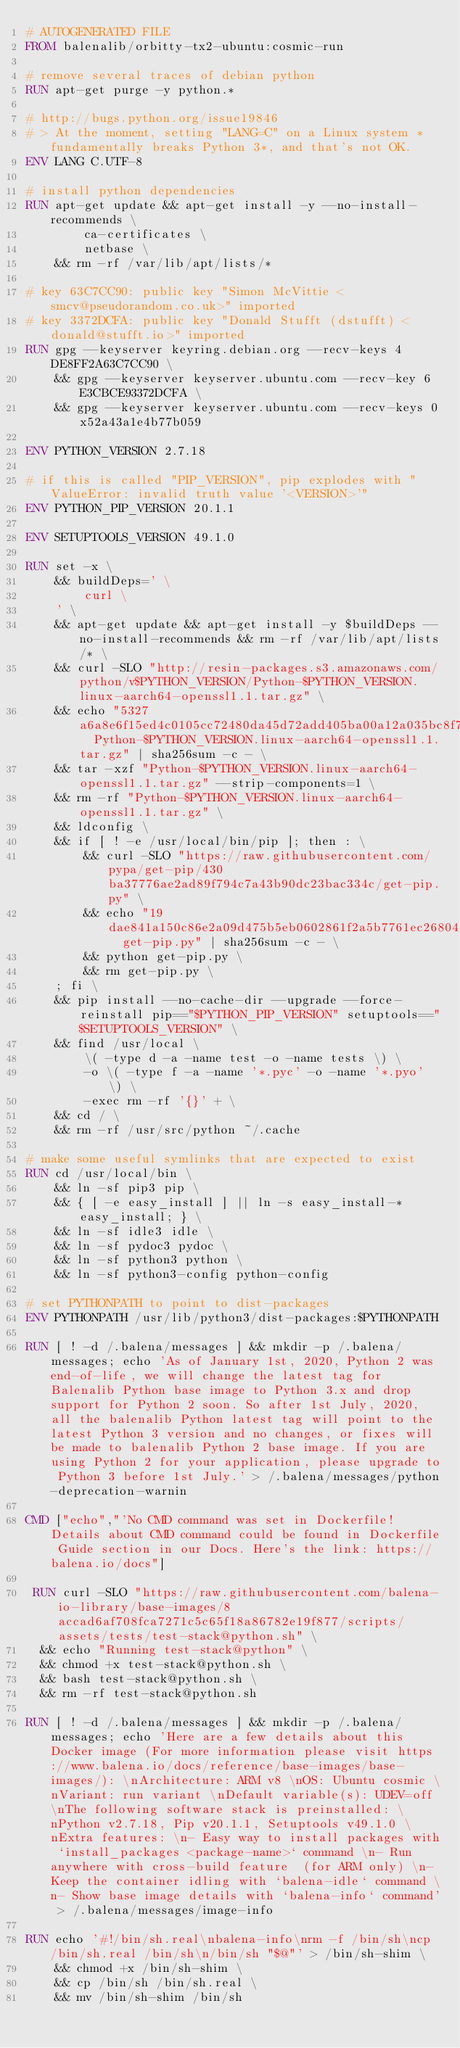Convert code to text. <code><loc_0><loc_0><loc_500><loc_500><_Dockerfile_># AUTOGENERATED FILE
FROM balenalib/orbitty-tx2-ubuntu:cosmic-run

# remove several traces of debian python
RUN apt-get purge -y python.*

# http://bugs.python.org/issue19846
# > At the moment, setting "LANG=C" on a Linux system *fundamentally breaks Python 3*, and that's not OK.
ENV LANG C.UTF-8

# install python dependencies
RUN apt-get update && apt-get install -y --no-install-recommends \
		ca-certificates \
		netbase \
	&& rm -rf /var/lib/apt/lists/*

# key 63C7CC90: public key "Simon McVittie <smcv@pseudorandom.co.uk>" imported
# key 3372DCFA: public key "Donald Stufft (dstufft) <donald@stufft.io>" imported
RUN gpg --keyserver keyring.debian.org --recv-keys 4DE8FF2A63C7CC90 \
	&& gpg --keyserver keyserver.ubuntu.com --recv-key 6E3CBCE93372DCFA \
	&& gpg --keyserver keyserver.ubuntu.com --recv-keys 0x52a43a1e4b77b059

ENV PYTHON_VERSION 2.7.18

# if this is called "PIP_VERSION", pip explodes with "ValueError: invalid truth value '<VERSION>'"
ENV PYTHON_PIP_VERSION 20.1.1

ENV SETUPTOOLS_VERSION 49.1.0

RUN set -x \
	&& buildDeps=' \
		curl \
	' \
	&& apt-get update && apt-get install -y $buildDeps --no-install-recommends && rm -rf /var/lib/apt/lists/* \
	&& curl -SLO "http://resin-packages.s3.amazonaws.com/python/v$PYTHON_VERSION/Python-$PYTHON_VERSION.linux-aarch64-openssl1.1.tar.gz" \
	&& echo "5327a6a8e6f15ed4c0105cc72480da45d72add405ba00a12a035bc8f7be76ee6  Python-$PYTHON_VERSION.linux-aarch64-openssl1.1.tar.gz" | sha256sum -c - \
	&& tar -xzf "Python-$PYTHON_VERSION.linux-aarch64-openssl1.1.tar.gz" --strip-components=1 \
	&& rm -rf "Python-$PYTHON_VERSION.linux-aarch64-openssl1.1.tar.gz" \
	&& ldconfig \
	&& if [ ! -e /usr/local/bin/pip ]; then : \
		&& curl -SLO "https://raw.githubusercontent.com/pypa/get-pip/430ba37776ae2ad89f794c7a43b90dc23bac334c/get-pip.py" \
		&& echo "19dae841a150c86e2a09d475b5eb0602861f2a5b7761ec268049a662dbd2bd0c  get-pip.py" | sha256sum -c - \
		&& python get-pip.py \
		&& rm get-pip.py \
	; fi \
	&& pip install --no-cache-dir --upgrade --force-reinstall pip=="$PYTHON_PIP_VERSION" setuptools=="$SETUPTOOLS_VERSION" \
	&& find /usr/local \
		\( -type d -a -name test -o -name tests \) \
		-o \( -type f -a -name '*.pyc' -o -name '*.pyo' \) \
		-exec rm -rf '{}' + \
	&& cd / \
	&& rm -rf /usr/src/python ~/.cache

# make some useful symlinks that are expected to exist
RUN cd /usr/local/bin \
	&& ln -sf pip3 pip \
	&& { [ -e easy_install ] || ln -s easy_install-* easy_install; } \
	&& ln -sf idle3 idle \
	&& ln -sf pydoc3 pydoc \
	&& ln -sf python3 python \
	&& ln -sf python3-config python-config

# set PYTHONPATH to point to dist-packages
ENV PYTHONPATH /usr/lib/python3/dist-packages:$PYTHONPATH

RUN [ ! -d /.balena/messages ] && mkdir -p /.balena/messages; echo 'As of January 1st, 2020, Python 2 was end-of-life, we will change the latest tag for Balenalib Python base image to Python 3.x and drop support for Python 2 soon. So after 1st July, 2020, all the balenalib Python latest tag will point to the latest Python 3 version and no changes, or fixes will be made to balenalib Python 2 base image. If you are using Python 2 for your application, please upgrade to Python 3 before 1st July.' > /.balena/messages/python-deprecation-warnin

CMD ["echo","'No CMD command was set in Dockerfile! Details about CMD command could be found in Dockerfile Guide section in our Docs. Here's the link: https://balena.io/docs"]

 RUN curl -SLO "https://raw.githubusercontent.com/balena-io-library/base-images/8accad6af708fca7271c5c65f18a86782e19f877/scripts/assets/tests/test-stack@python.sh" \
  && echo "Running test-stack@python" \
  && chmod +x test-stack@python.sh \
  && bash test-stack@python.sh \
  && rm -rf test-stack@python.sh 

RUN [ ! -d /.balena/messages ] && mkdir -p /.balena/messages; echo 'Here are a few details about this Docker image (For more information please visit https://www.balena.io/docs/reference/base-images/base-images/): \nArchitecture: ARM v8 \nOS: Ubuntu cosmic \nVariant: run variant \nDefault variable(s): UDEV=off \nThe following software stack is preinstalled: \nPython v2.7.18, Pip v20.1.1, Setuptools v49.1.0 \nExtra features: \n- Easy way to install packages with `install_packages <package-name>` command \n- Run anywhere with cross-build feature  (for ARM only) \n- Keep the container idling with `balena-idle` command \n- Show base image details with `balena-info` command' > /.balena/messages/image-info

RUN echo '#!/bin/sh.real\nbalena-info\nrm -f /bin/sh\ncp /bin/sh.real /bin/sh\n/bin/sh "$@"' > /bin/sh-shim \
	&& chmod +x /bin/sh-shim \
	&& cp /bin/sh /bin/sh.real \
	&& mv /bin/sh-shim /bin/sh</code> 